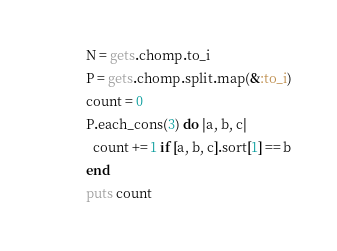Convert code to text. <code><loc_0><loc_0><loc_500><loc_500><_Ruby_>N = gets.chomp.to_i
P = gets.chomp.split.map(&:to_i)
count = 0
P.each_cons(3) do |a, b, c|
  count += 1 if [a, b, c].sort[1] == b
end
puts count
</code> 